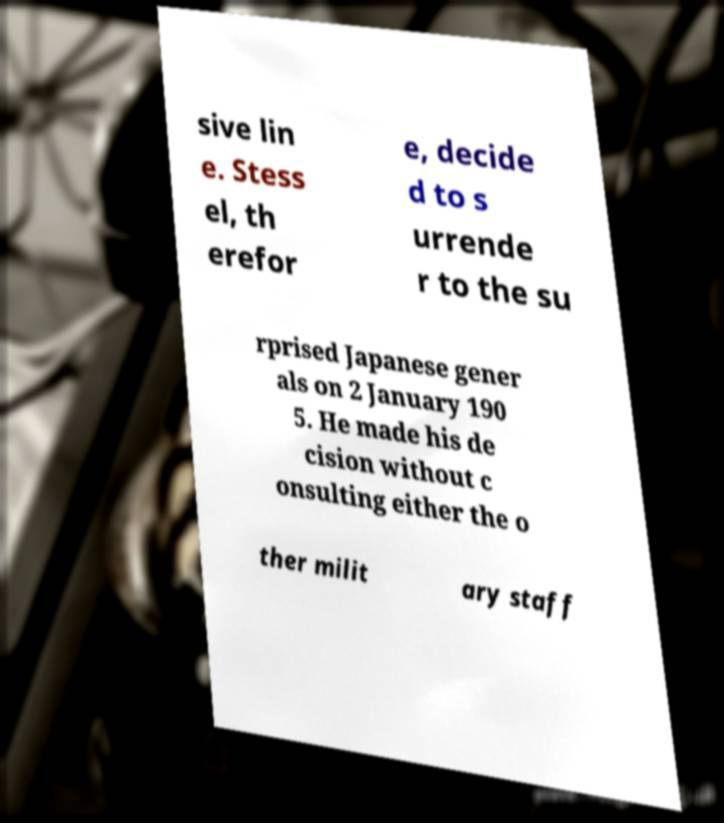Could you extract and type out the text from this image? sive lin e. Stess el, th erefor e, decide d to s urrende r to the su rprised Japanese gener als on 2 January 190 5. He made his de cision without c onsulting either the o ther milit ary staff 